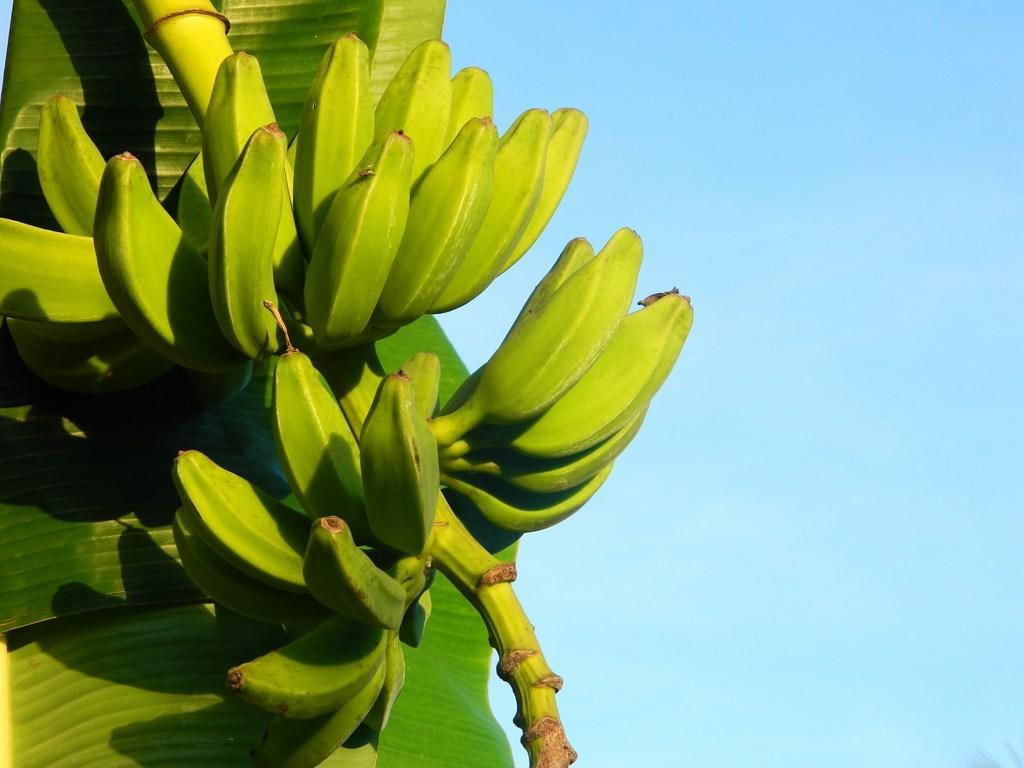In one or two sentences, can you explain what this image depicts? In this picture there is banana tree in the image. 